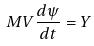<formula> <loc_0><loc_0><loc_500><loc_500>M V \frac { d \psi } { d t } = Y</formula> 